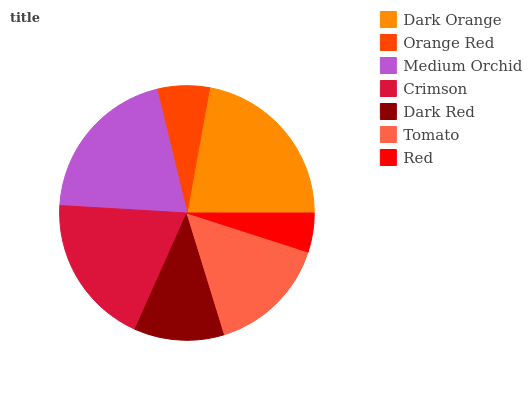Is Red the minimum?
Answer yes or no. Yes. Is Dark Orange the maximum?
Answer yes or no. Yes. Is Orange Red the minimum?
Answer yes or no. No. Is Orange Red the maximum?
Answer yes or no. No. Is Dark Orange greater than Orange Red?
Answer yes or no. Yes. Is Orange Red less than Dark Orange?
Answer yes or no. Yes. Is Orange Red greater than Dark Orange?
Answer yes or no. No. Is Dark Orange less than Orange Red?
Answer yes or no. No. Is Tomato the high median?
Answer yes or no. Yes. Is Tomato the low median?
Answer yes or no. Yes. Is Medium Orchid the high median?
Answer yes or no. No. Is Orange Red the low median?
Answer yes or no. No. 